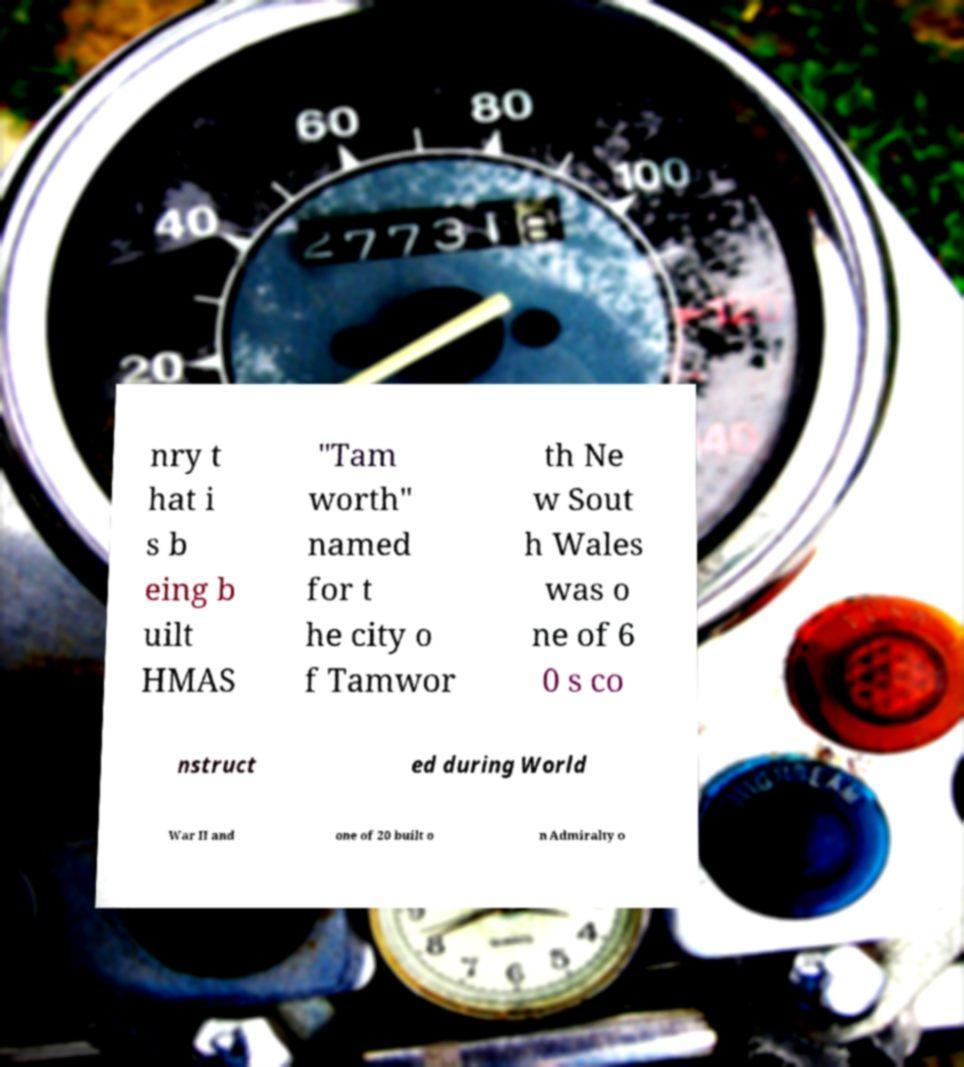Could you extract and type out the text from this image? nry t hat i s b eing b uilt HMAS "Tam worth" named for t he city o f Tamwor th Ne w Sout h Wales was o ne of 6 0 s co nstruct ed during World War II and one of 20 built o n Admiralty o 